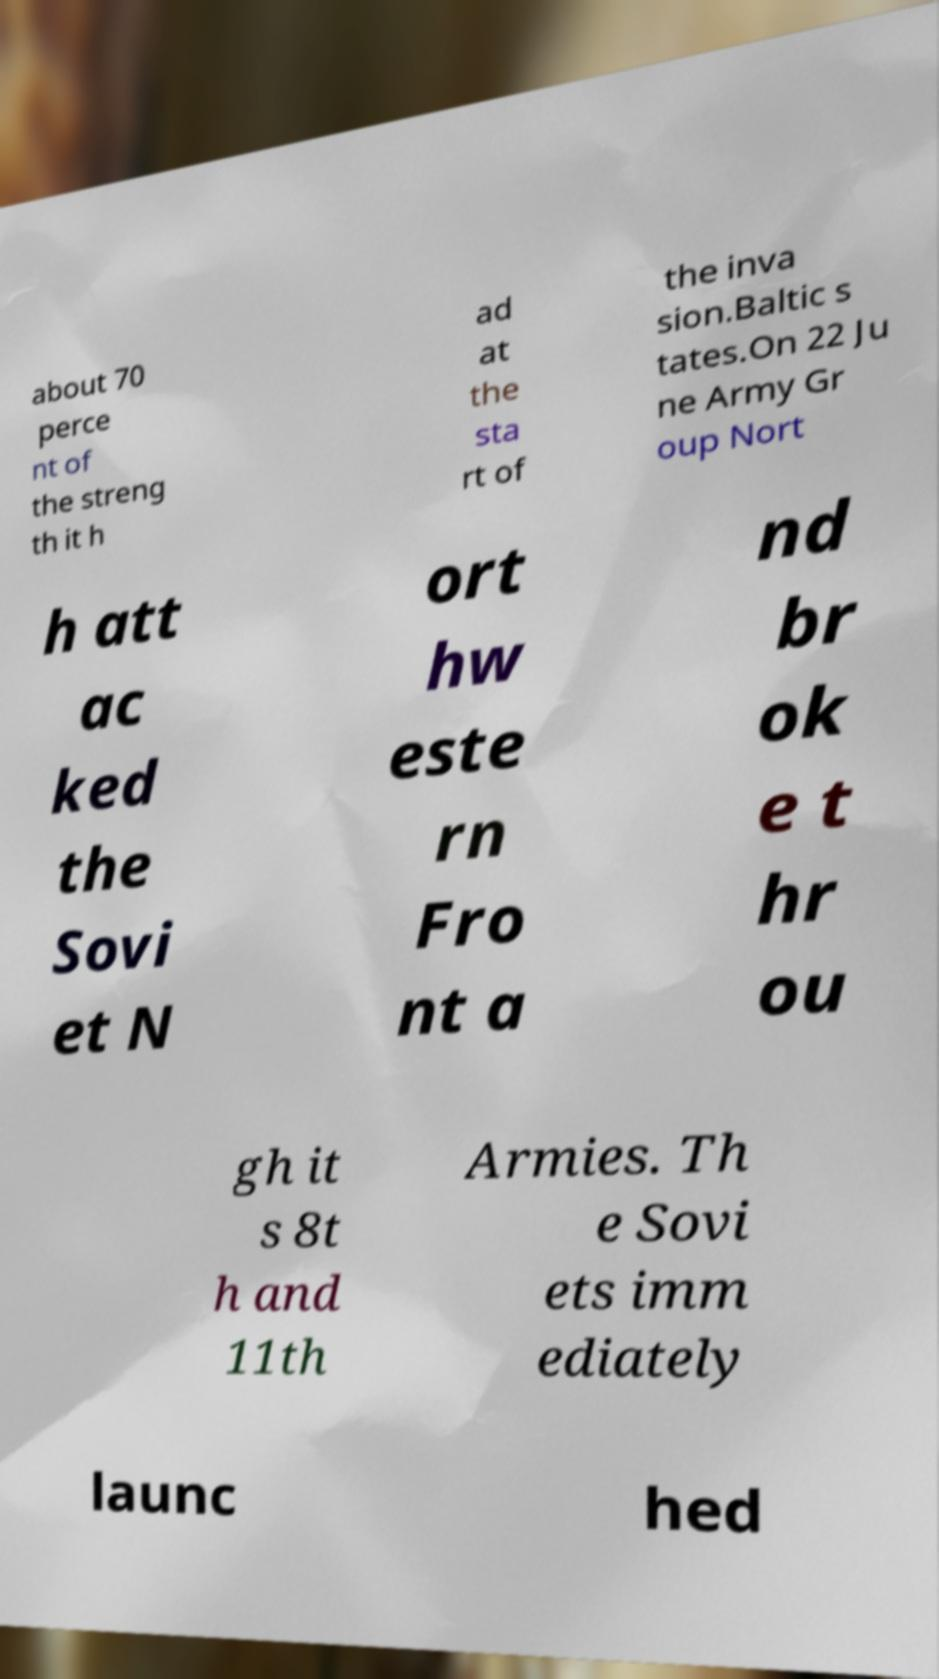Please read and relay the text visible in this image. What does it say? about 70 perce nt of the streng th it h ad at the sta rt of the inva sion.Baltic s tates.On 22 Ju ne Army Gr oup Nort h att ac ked the Sovi et N ort hw este rn Fro nt a nd br ok e t hr ou gh it s 8t h and 11th Armies. Th e Sovi ets imm ediately launc hed 